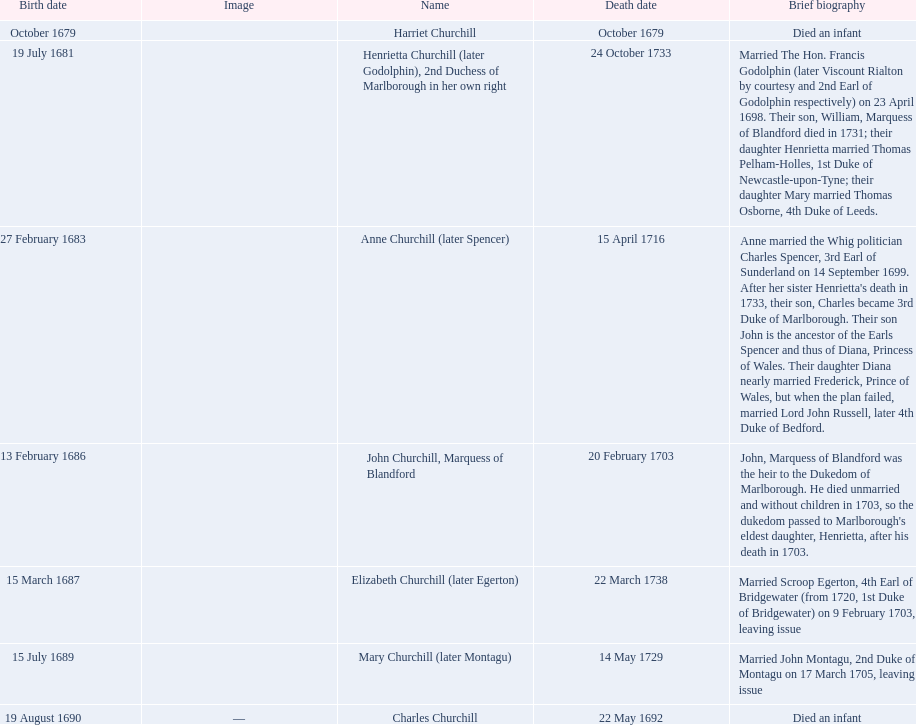What is the number of children sarah churchill had? 7. 